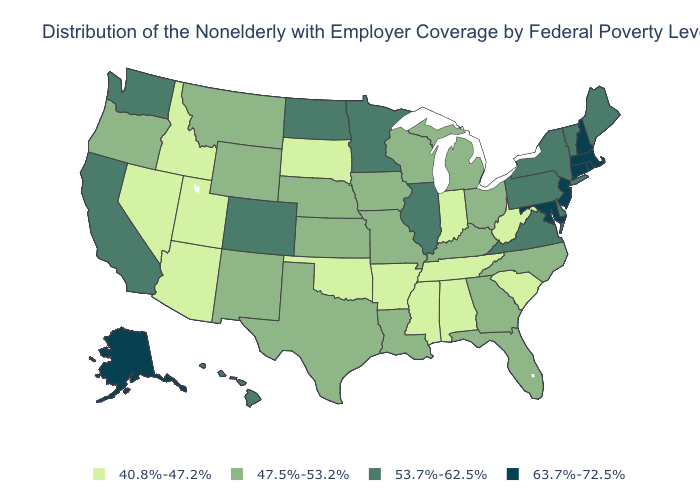Which states have the lowest value in the USA?
Answer briefly. Alabama, Arizona, Arkansas, Idaho, Indiana, Mississippi, Nevada, Oklahoma, South Carolina, South Dakota, Tennessee, Utah, West Virginia. What is the value of Alaska?
Concise answer only. 63.7%-72.5%. Does the first symbol in the legend represent the smallest category?
Quick response, please. Yes. Does South Dakota have the lowest value in the USA?
Give a very brief answer. Yes. Which states have the highest value in the USA?
Give a very brief answer. Alaska, Connecticut, Maryland, Massachusetts, New Hampshire, New Jersey, Rhode Island. What is the value of Louisiana?
Be succinct. 47.5%-53.2%. Name the states that have a value in the range 53.7%-62.5%?
Quick response, please. California, Colorado, Delaware, Hawaii, Illinois, Maine, Minnesota, New York, North Dakota, Pennsylvania, Vermont, Virginia, Washington. Name the states that have a value in the range 40.8%-47.2%?
Give a very brief answer. Alabama, Arizona, Arkansas, Idaho, Indiana, Mississippi, Nevada, Oklahoma, South Carolina, South Dakota, Tennessee, Utah, West Virginia. What is the lowest value in the USA?
Concise answer only. 40.8%-47.2%. Among the states that border Oklahoma , which have the lowest value?
Short answer required. Arkansas. What is the highest value in the USA?
Be succinct. 63.7%-72.5%. Does South Dakota have the lowest value in the USA?
Answer briefly. Yes. Name the states that have a value in the range 47.5%-53.2%?
Keep it brief. Florida, Georgia, Iowa, Kansas, Kentucky, Louisiana, Michigan, Missouri, Montana, Nebraska, New Mexico, North Carolina, Ohio, Oregon, Texas, Wisconsin, Wyoming. Does North Dakota have the highest value in the MidWest?
Answer briefly. Yes. What is the value of Massachusetts?
Keep it brief. 63.7%-72.5%. 